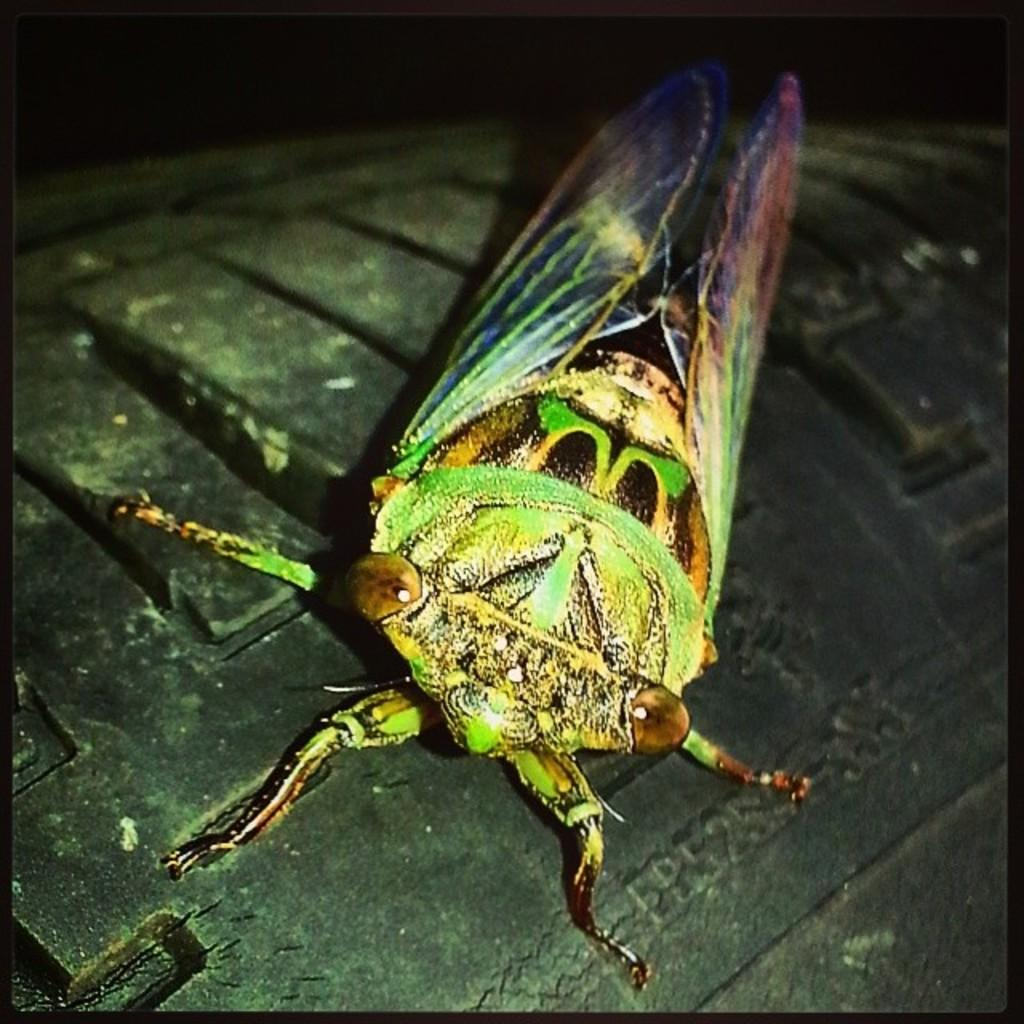What type of creature can be seen in the image? There is an insect in the image. Where is the insect located? The insect is present on a tire. What is the main subject in the center of the image? The tire is in the center of the image. What type of beast can be seen standing on the neck of the rock in the image? There is no beast, neck, or rock present in the image. 